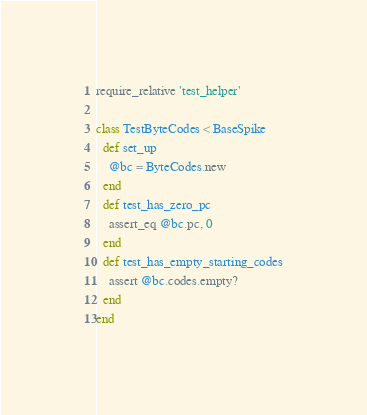<code> <loc_0><loc_0><loc_500><loc_500><_Ruby_>
require_relative 'test_helper'

class TestByteCodes < BaseSpike
  def set_up
    @bc = ByteCodes.new
  end
  def test_has_zero_pc
    assert_eq @bc.pc, 0
  end
  def test_has_empty_starting_codes
    assert @bc.codes.empty?
  end
end</code> 